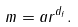Convert formula to latex. <formula><loc_0><loc_0><loc_500><loc_500>m = a r ^ { d _ { f } } .</formula> 